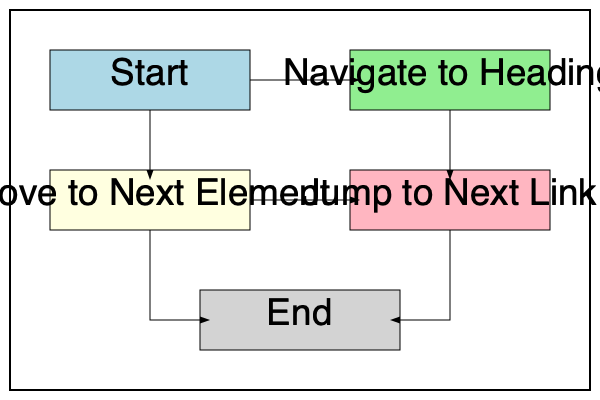Based on the flowchart representing keyboard shortcuts for efficient screen reader navigation, which shortcut would be most appropriate to use when looking for a specific section on a webpage? To determine the most appropriate shortcut for finding a specific section on a webpage using a screen reader, let's analyze the flowchart:

1. The flowchart starts with a "Start" node, indicating the beginning of the navigation process.

2. From the start, we have two initial options:
   a. "Navigate to Heading"
   b. "Move to Next Element"

3. The "Navigate to Heading" option is directly connected to the start, suggesting it's a primary navigation method.

4. Headings are typically used to structure content on webpages, dividing them into sections and subsections.

5. Using the "Navigate to Heading" shortcut allows users to quickly jump between major sections of a webpage without having to go through each element sequentially.

6. The "Move to Next Element" option, while useful for detailed exploration, would be less efficient for finding a specific section quickly.

7. The "Jump to Next Link" option, while helpful for navigating between links, is not as effective for finding specific content sections.

Given this analysis, the most appropriate shortcut for efficiently locating a specific section on a webpage would be the one that allows navigation between headings. This shortcut enables users to quickly scan the structure of the page and find the desired section without having to go through every element or link.
Answer: Navigate to Heading 